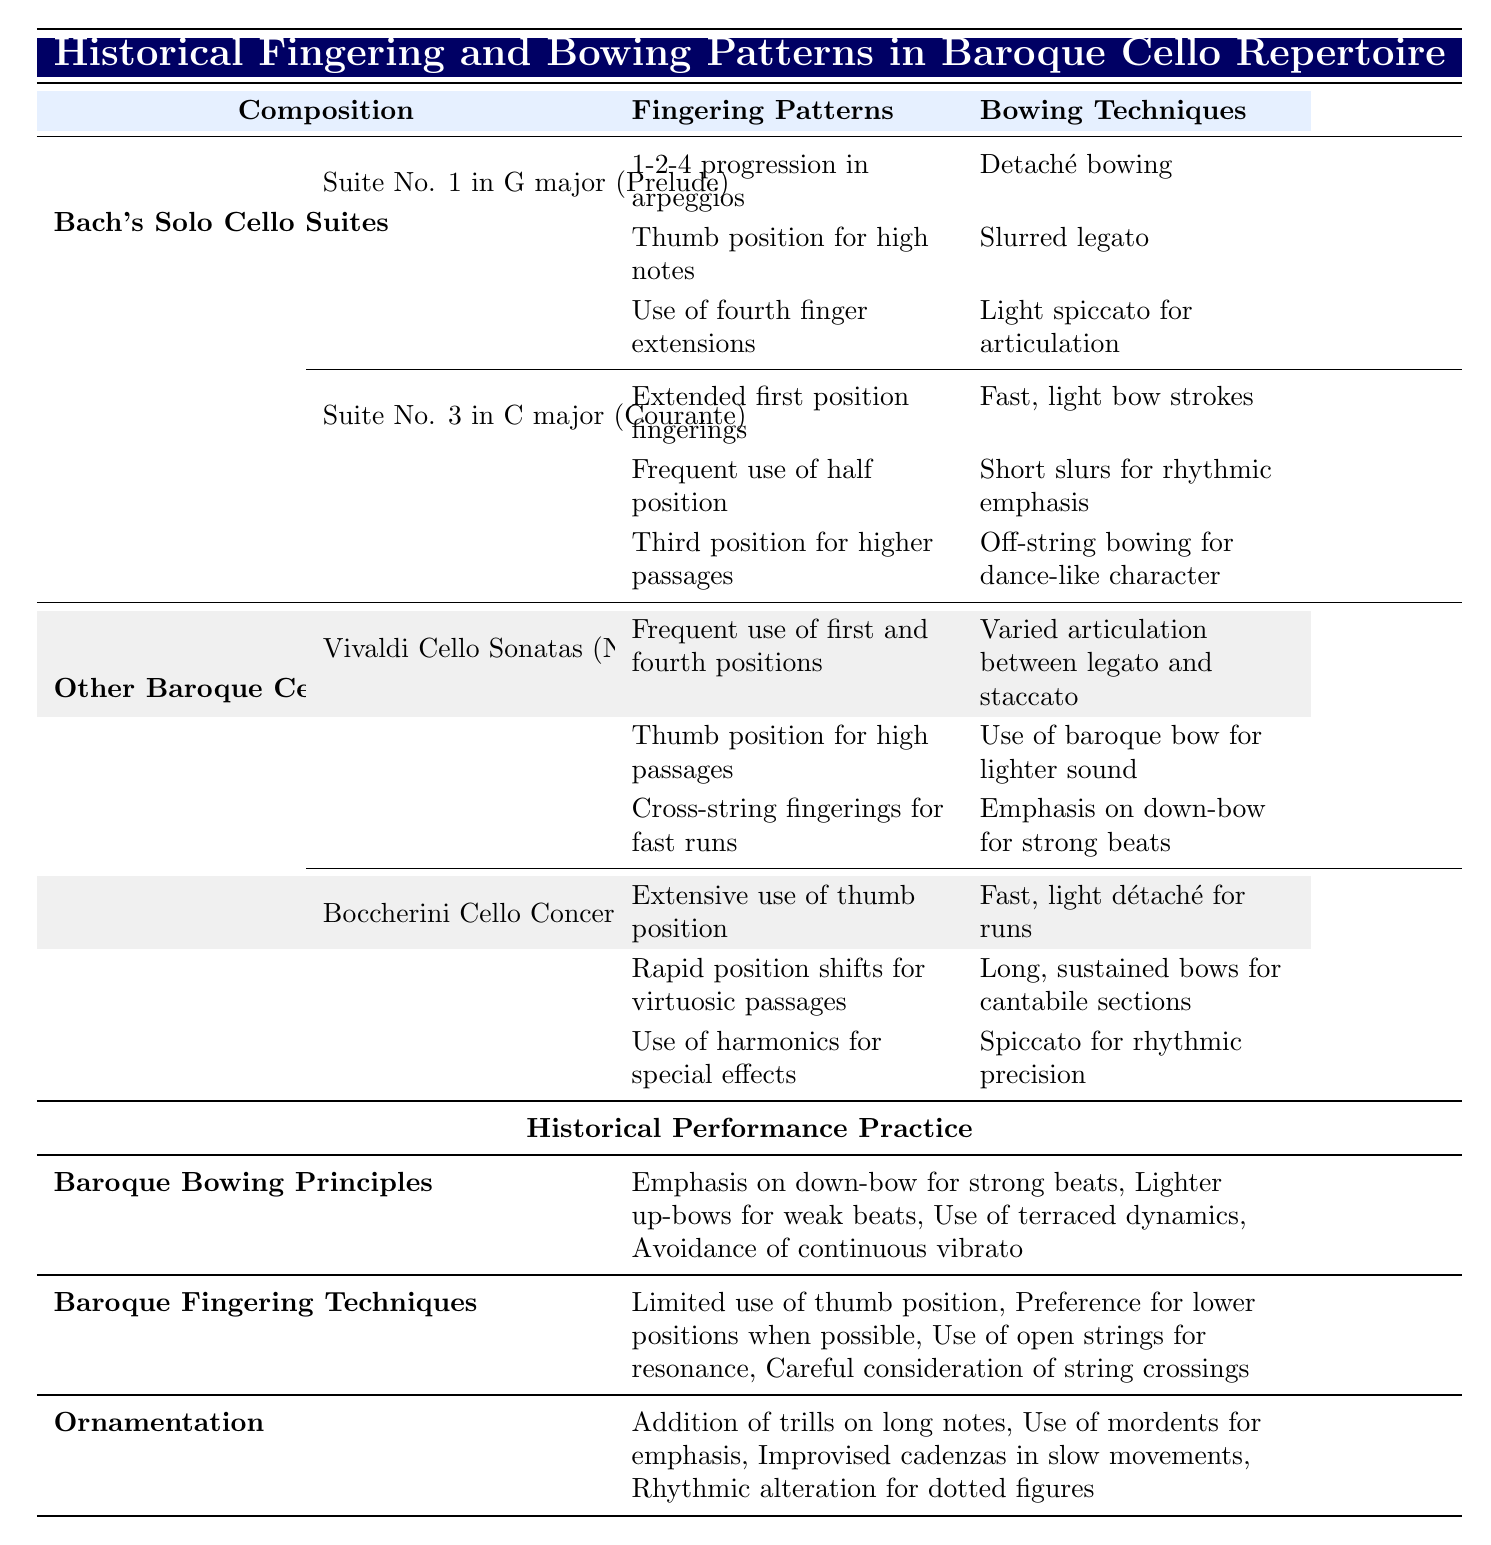What fingering patterns are used in Bach's Suite No. 1 Prelude? The table lists three fingering patterns for Bach's Suite No. 1 Prelude: "1-2-4 progression in arpeggios," "Thumb position for high notes," and "Use of fourth finger extensions."
Answer: Three: arpeggios progression, thumb position, fourth finger extensions What bowing techniques are used in the Sarabande from Bach's Suite No. 3? According to the table, the bowing techniques for the Sarabande include "Slow, sustained bow strokes," "Subtle bow pressure changes for dynamics," and "Use of vibrato to enhance long notes."
Answer: Three techniques: sustained bow strokes, pressure changes, vibrato Is "off-string bowing for dance-like character" used in Bach's Suite No. 3 Courante? Referring to the table, "off-string bowing for dance-like character" is listed under bowing techniques for the Courante from Suite No. 3. Therefore, this statement is true.
Answer: Yes Which composition utilizes thumb position for high notes? The table indicates that both Bach's Suite No. 1 Prelude and Vivaldi's Sonata No. 5 in E minor include thumb position for high passages. Thus, both compositions use this technique.
Answer: Suite No. 1 Prelude and Vivaldi's Sonata No. 5 How many distinct fingering patterns are listed for Vivaldi's Sonata No. 5 in E minor? The table shows that there are three distinct fingering patterns mentioned for Vivaldi's Sonata No. 5 in E minor: "Frequent use of first and fourth positions," "Thumb position for high passages," and "Cross-string fingerings for fast runs."
Answer: Three distinct fingerings What is the difference in the number of bowing techniques between Bach's Suite No. 3 Courante and Boccherini's Cello Concerto First Movement? The table displays three bowing techniques for Courante and three for Boccherini's First Movement, resulting in no difference. Therefore, both have an equal number of techniques.
Answer: No difference List the historical performance practices related to bowing techniques from the table. The table outlines four principles related to baroque bowing: "Emphasis on down-bow for strong beats," "Lighter up-bows for weak beats," "Use of terraced dynamics," and "Avoidance of continuous vibrato."
Answer: Four principles Do both Bach and Vivaldi employ shifts to thumb position in their cello suites? Based on the table, both composers utilize thumb position: Bach in Suite No. 1 Prelude and Vivaldi's Sonata No. 5. This confirms that both employ this technique.
Answer: Yes What bowing technique is unique to Boccherini's Cello Concerto compared to Bach's Suites? The table specifies "Spiccato for rhythmic precision" as a bowing technique unique to Boccherini's Cello Concerto that is not listed in Bach's Suites.
Answer: Spiccato for rhythmic precision Are all compositions in the table related to the Baroque period? The table mentions compositions and practices specifically denoted as part of baroque cello repertoire and principles, indicating that all compositions are indeed related to the Baroque period.
Answer: Yes What are the potential rhythmic emphases presented in the bowing techniques of Bach's Suite No. 3 Courante? The table outlines the bowing techniques for Courante as "Fast, light bow strokes," "Short slurs for rhythmic emphasis," and "Off-string bowing for dance-like character," indicating a dance focus commonly found in baroque compositions.
Answer: Three: light strokes, short slurs, off-string 